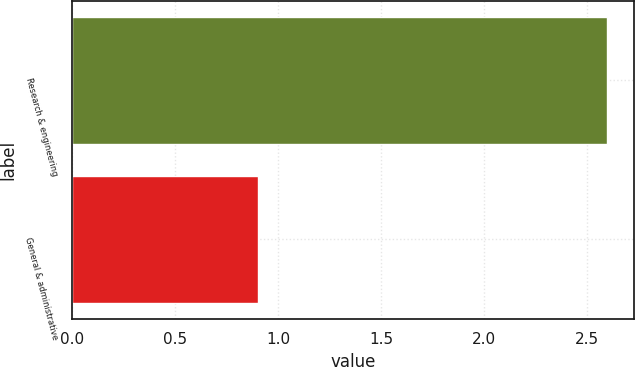Convert chart. <chart><loc_0><loc_0><loc_500><loc_500><bar_chart><fcel>Research & engineering<fcel>General & administrative<nl><fcel>2.6<fcel>0.9<nl></chart> 